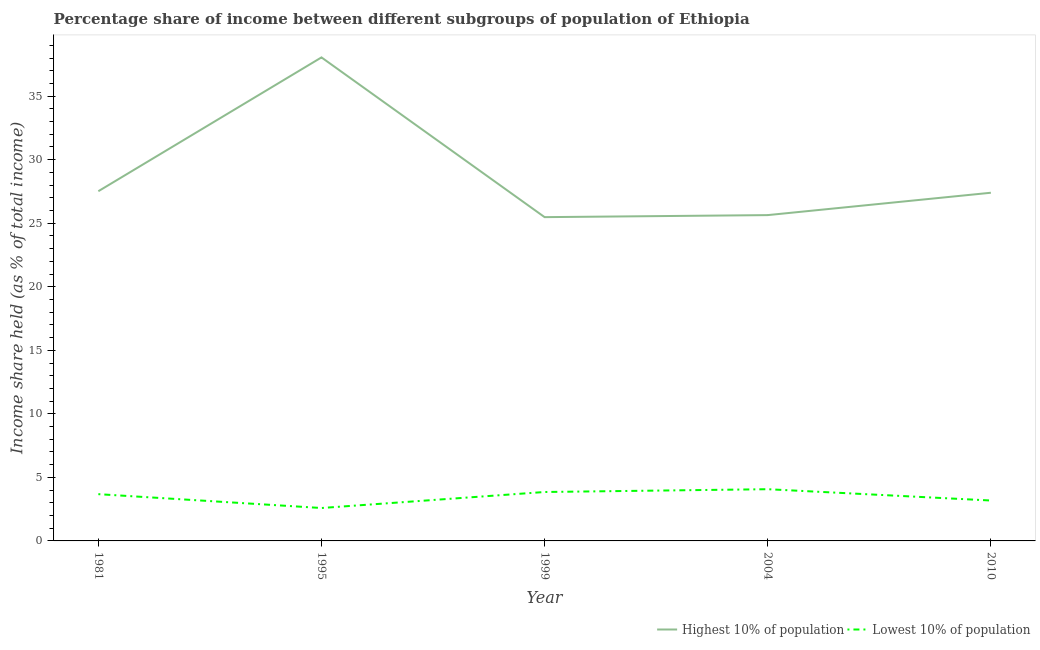What is the income share held by highest 10% of the population in 1999?
Give a very brief answer. 25.48. Across all years, what is the maximum income share held by lowest 10% of the population?
Ensure brevity in your answer.  4.07. Across all years, what is the minimum income share held by lowest 10% of the population?
Ensure brevity in your answer.  2.59. In which year was the income share held by lowest 10% of the population minimum?
Your answer should be very brief. 1995. What is the total income share held by highest 10% of the population in the graph?
Your answer should be compact. 144.09. What is the difference between the income share held by highest 10% of the population in 1995 and that in 2004?
Your answer should be compact. 12.41. What is the difference between the income share held by highest 10% of the population in 1995 and the income share held by lowest 10% of the population in 2010?
Provide a short and direct response. 34.87. What is the average income share held by lowest 10% of the population per year?
Your answer should be compact. 3.47. In the year 1995, what is the difference between the income share held by lowest 10% of the population and income share held by highest 10% of the population?
Give a very brief answer. -35.46. In how many years, is the income share held by lowest 10% of the population greater than 3 %?
Make the answer very short. 4. What is the ratio of the income share held by highest 10% of the population in 1981 to that in 1995?
Your answer should be compact. 0.72. Is the income share held by lowest 10% of the population in 1995 less than that in 2004?
Offer a terse response. Yes. What is the difference between the highest and the second highest income share held by highest 10% of the population?
Make the answer very short. 10.53. What is the difference between the highest and the lowest income share held by lowest 10% of the population?
Provide a short and direct response. 1.48. In how many years, is the income share held by lowest 10% of the population greater than the average income share held by lowest 10% of the population taken over all years?
Provide a succinct answer. 3. Is the sum of the income share held by highest 10% of the population in 1995 and 1999 greater than the maximum income share held by lowest 10% of the population across all years?
Offer a very short reply. Yes. Is the income share held by highest 10% of the population strictly greater than the income share held by lowest 10% of the population over the years?
Offer a terse response. Yes. Is the income share held by highest 10% of the population strictly less than the income share held by lowest 10% of the population over the years?
Give a very brief answer. No. How many lines are there?
Provide a short and direct response. 2. Are the values on the major ticks of Y-axis written in scientific E-notation?
Provide a short and direct response. No. Does the graph contain grids?
Offer a very short reply. No. Where does the legend appear in the graph?
Provide a short and direct response. Bottom right. How are the legend labels stacked?
Your response must be concise. Horizontal. What is the title of the graph?
Provide a succinct answer. Percentage share of income between different subgroups of population of Ethiopia. What is the label or title of the X-axis?
Ensure brevity in your answer.  Year. What is the label or title of the Y-axis?
Keep it short and to the point. Income share held (as % of total income). What is the Income share held (as % of total income) in Highest 10% of population in 1981?
Provide a short and direct response. 27.52. What is the Income share held (as % of total income) in Lowest 10% of population in 1981?
Keep it short and to the point. 3.68. What is the Income share held (as % of total income) of Highest 10% of population in 1995?
Give a very brief answer. 38.05. What is the Income share held (as % of total income) of Lowest 10% of population in 1995?
Keep it short and to the point. 2.59. What is the Income share held (as % of total income) in Highest 10% of population in 1999?
Your response must be concise. 25.48. What is the Income share held (as % of total income) in Lowest 10% of population in 1999?
Your answer should be compact. 3.85. What is the Income share held (as % of total income) of Highest 10% of population in 2004?
Offer a very short reply. 25.64. What is the Income share held (as % of total income) in Lowest 10% of population in 2004?
Your answer should be compact. 4.07. What is the Income share held (as % of total income) of Highest 10% of population in 2010?
Provide a succinct answer. 27.4. What is the Income share held (as % of total income) in Lowest 10% of population in 2010?
Offer a terse response. 3.18. Across all years, what is the maximum Income share held (as % of total income) of Highest 10% of population?
Your answer should be very brief. 38.05. Across all years, what is the maximum Income share held (as % of total income) in Lowest 10% of population?
Offer a terse response. 4.07. Across all years, what is the minimum Income share held (as % of total income) in Highest 10% of population?
Ensure brevity in your answer.  25.48. Across all years, what is the minimum Income share held (as % of total income) in Lowest 10% of population?
Provide a succinct answer. 2.59. What is the total Income share held (as % of total income) in Highest 10% of population in the graph?
Provide a succinct answer. 144.09. What is the total Income share held (as % of total income) of Lowest 10% of population in the graph?
Your response must be concise. 17.37. What is the difference between the Income share held (as % of total income) in Highest 10% of population in 1981 and that in 1995?
Provide a short and direct response. -10.53. What is the difference between the Income share held (as % of total income) in Lowest 10% of population in 1981 and that in 1995?
Offer a very short reply. 1.09. What is the difference between the Income share held (as % of total income) of Highest 10% of population in 1981 and that in 1999?
Your answer should be very brief. 2.04. What is the difference between the Income share held (as % of total income) of Lowest 10% of population in 1981 and that in 1999?
Your response must be concise. -0.17. What is the difference between the Income share held (as % of total income) in Highest 10% of population in 1981 and that in 2004?
Offer a terse response. 1.88. What is the difference between the Income share held (as % of total income) in Lowest 10% of population in 1981 and that in 2004?
Give a very brief answer. -0.39. What is the difference between the Income share held (as % of total income) of Highest 10% of population in 1981 and that in 2010?
Offer a very short reply. 0.12. What is the difference between the Income share held (as % of total income) in Lowest 10% of population in 1981 and that in 2010?
Ensure brevity in your answer.  0.5. What is the difference between the Income share held (as % of total income) of Highest 10% of population in 1995 and that in 1999?
Offer a very short reply. 12.57. What is the difference between the Income share held (as % of total income) of Lowest 10% of population in 1995 and that in 1999?
Your answer should be very brief. -1.26. What is the difference between the Income share held (as % of total income) of Highest 10% of population in 1995 and that in 2004?
Offer a very short reply. 12.41. What is the difference between the Income share held (as % of total income) in Lowest 10% of population in 1995 and that in 2004?
Your answer should be very brief. -1.48. What is the difference between the Income share held (as % of total income) in Highest 10% of population in 1995 and that in 2010?
Your answer should be compact. 10.65. What is the difference between the Income share held (as % of total income) in Lowest 10% of population in 1995 and that in 2010?
Make the answer very short. -0.59. What is the difference between the Income share held (as % of total income) in Highest 10% of population in 1999 and that in 2004?
Provide a short and direct response. -0.16. What is the difference between the Income share held (as % of total income) of Lowest 10% of population in 1999 and that in 2004?
Provide a short and direct response. -0.22. What is the difference between the Income share held (as % of total income) of Highest 10% of population in 1999 and that in 2010?
Keep it short and to the point. -1.92. What is the difference between the Income share held (as % of total income) in Lowest 10% of population in 1999 and that in 2010?
Provide a short and direct response. 0.67. What is the difference between the Income share held (as % of total income) in Highest 10% of population in 2004 and that in 2010?
Give a very brief answer. -1.76. What is the difference between the Income share held (as % of total income) of Lowest 10% of population in 2004 and that in 2010?
Make the answer very short. 0.89. What is the difference between the Income share held (as % of total income) in Highest 10% of population in 1981 and the Income share held (as % of total income) in Lowest 10% of population in 1995?
Offer a terse response. 24.93. What is the difference between the Income share held (as % of total income) of Highest 10% of population in 1981 and the Income share held (as % of total income) of Lowest 10% of population in 1999?
Ensure brevity in your answer.  23.67. What is the difference between the Income share held (as % of total income) in Highest 10% of population in 1981 and the Income share held (as % of total income) in Lowest 10% of population in 2004?
Your answer should be compact. 23.45. What is the difference between the Income share held (as % of total income) of Highest 10% of population in 1981 and the Income share held (as % of total income) of Lowest 10% of population in 2010?
Keep it short and to the point. 24.34. What is the difference between the Income share held (as % of total income) of Highest 10% of population in 1995 and the Income share held (as % of total income) of Lowest 10% of population in 1999?
Make the answer very short. 34.2. What is the difference between the Income share held (as % of total income) of Highest 10% of population in 1995 and the Income share held (as % of total income) of Lowest 10% of population in 2004?
Your answer should be compact. 33.98. What is the difference between the Income share held (as % of total income) in Highest 10% of population in 1995 and the Income share held (as % of total income) in Lowest 10% of population in 2010?
Offer a very short reply. 34.87. What is the difference between the Income share held (as % of total income) in Highest 10% of population in 1999 and the Income share held (as % of total income) in Lowest 10% of population in 2004?
Offer a terse response. 21.41. What is the difference between the Income share held (as % of total income) of Highest 10% of population in 1999 and the Income share held (as % of total income) of Lowest 10% of population in 2010?
Give a very brief answer. 22.3. What is the difference between the Income share held (as % of total income) of Highest 10% of population in 2004 and the Income share held (as % of total income) of Lowest 10% of population in 2010?
Offer a very short reply. 22.46. What is the average Income share held (as % of total income) in Highest 10% of population per year?
Keep it short and to the point. 28.82. What is the average Income share held (as % of total income) of Lowest 10% of population per year?
Provide a short and direct response. 3.47. In the year 1981, what is the difference between the Income share held (as % of total income) of Highest 10% of population and Income share held (as % of total income) of Lowest 10% of population?
Provide a short and direct response. 23.84. In the year 1995, what is the difference between the Income share held (as % of total income) in Highest 10% of population and Income share held (as % of total income) in Lowest 10% of population?
Give a very brief answer. 35.46. In the year 1999, what is the difference between the Income share held (as % of total income) in Highest 10% of population and Income share held (as % of total income) in Lowest 10% of population?
Give a very brief answer. 21.63. In the year 2004, what is the difference between the Income share held (as % of total income) of Highest 10% of population and Income share held (as % of total income) of Lowest 10% of population?
Your answer should be compact. 21.57. In the year 2010, what is the difference between the Income share held (as % of total income) in Highest 10% of population and Income share held (as % of total income) in Lowest 10% of population?
Ensure brevity in your answer.  24.22. What is the ratio of the Income share held (as % of total income) in Highest 10% of population in 1981 to that in 1995?
Provide a succinct answer. 0.72. What is the ratio of the Income share held (as % of total income) in Lowest 10% of population in 1981 to that in 1995?
Offer a very short reply. 1.42. What is the ratio of the Income share held (as % of total income) in Highest 10% of population in 1981 to that in 1999?
Provide a succinct answer. 1.08. What is the ratio of the Income share held (as % of total income) in Lowest 10% of population in 1981 to that in 1999?
Your answer should be compact. 0.96. What is the ratio of the Income share held (as % of total income) of Highest 10% of population in 1981 to that in 2004?
Your answer should be compact. 1.07. What is the ratio of the Income share held (as % of total income) of Lowest 10% of population in 1981 to that in 2004?
Offer a very short reply. 0.9. What is the ratio of the Income share held (as % of total income) of Highest 10% of population in 1981 to that in 2010?
Provide a succinct answer. 1. What is the ratio of the Income share held (as % of total income) in Lowest 10% of population in 1981 to that in 2010?
Ensure brevity in your answer.  1.16. What is the ratio of the Income share held (as % of total income) of Highest 10% of population in 1995 to that in 1999?
Your answer should be compact. 1.49. What is the ratio of the Income share held (as % of total income) in Lowest 10% of population in 1995 to that in 1999?
Give a very brief answer. 0.67. What is the ratio of the Income share held (as % of total income) of Highest 10% of population in 1995 to that in 2004?
Offer a terse response. 1.48. What is the ratio of the Income share held (as % of total income) in Lowest 10% of population in 1995 to that in 2004?
Offer a very short reply. 0.64. What is the ratio of the Income share held (as % of total income) in Highest 10% of population in 1995 to that in 2010?
Offer a very short reply. 1.39. What is the ratio of the Income share held (as % of total income) in Lowest 10% of population in 1995 to that in 2010?
Your answer should be compact. 0.81. What is the ratio of the Income share held (as % of total income) of Lowest 10% of population in 1999 to that in 2004?
Your answer should be compact. 0.95. What is the ratio of the Income share held (as % of total income) of Highest 10% of population in 1999 to that in 2010?
Your answer should be compact. 0.93. What is the ratio of the Income share held (as % of total income) in Lowest 10% of population in 1999 to that in 2010?
Make the answer very short. 1.21. What is the ratio of the Income share held (as % of total income) of Highest 10% of population in 2004 to that in 2010?
Offer a very short reply. 0.94. What is the ratio of the Income share held (as % of total income) in Lowest 10% of population in 2004 to that in 2010?
Your response must be concise. 1.28. What is the difference between the highest and the second highest Income share held (as % of total income) in Highest 10% of population?
Provide a short and direct response. 10.53. What is the difference between the highest and the second highest Income share held (as % of total income) in Lowest 10% of population?
Provide a short and direct response. 0.22. What is the difference between the highest and the lowest Income share held (as % of total income) in Highest 10% of population?
Provide a succinct answer. 12.57. What is the difference between the highest and the lowest Income share held (as % of total income) of Lowest 10% of population?
Your response must be concise. 1.48. 